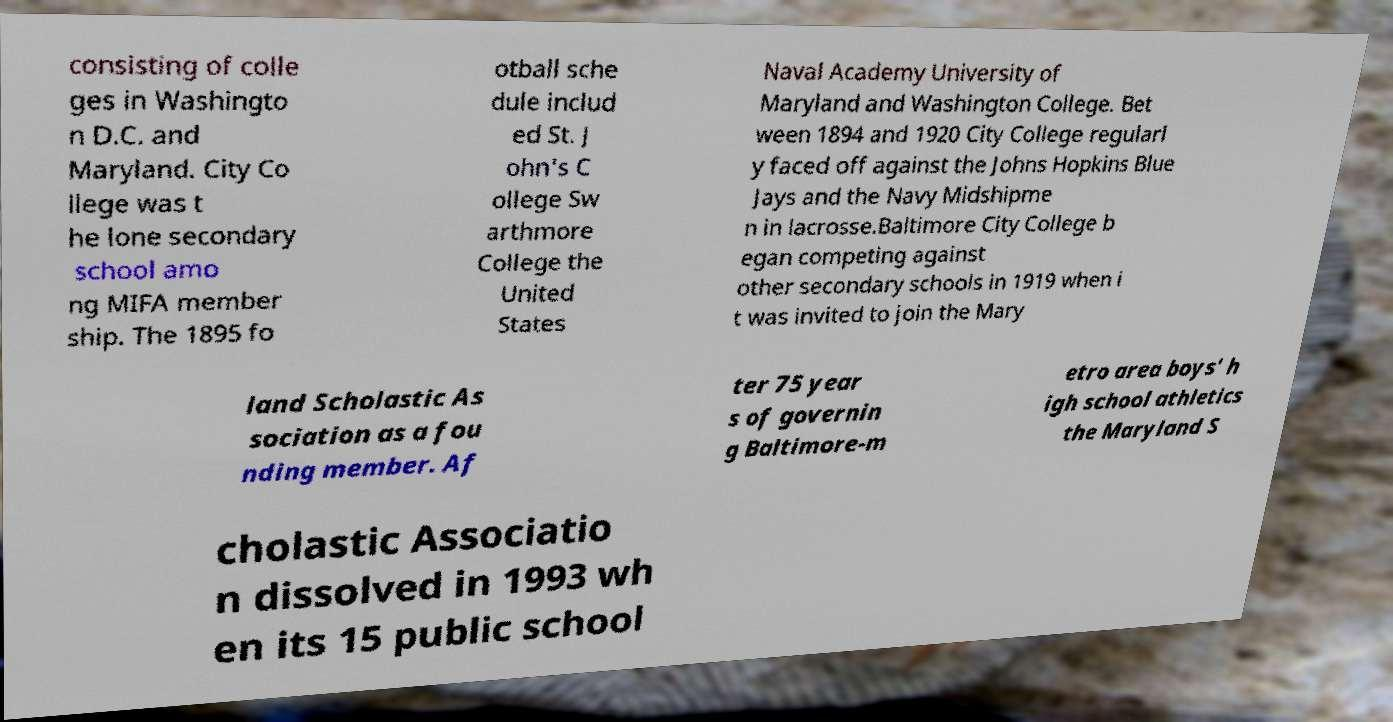Please identify and transcribe the text found in this image. consisting of colle ges in Washingto n D.C. and Maryland. City Co llege was t he lone secondary school amo ng MIFA member ship. The 1895 fo otball sche dule includ ed St. J ohn's C ollege Sw arthmore College the United States Naval Academy University of Maryland and Washington College. Bet ween 1894 and 1920 City College regularl y faced off against the Johns Hopkins Blue Jays and the Navy Midshipme n in lacrosse.Baltimore City College b egan competing against other secondary schools in 1919 when i t was invited to join the Mary land Scholastic As sociation as a fou nding member. Af ter 75 year s of governin g Baltimore-m etro area boys' h igh school athletics the Maryland S cholastic Associatio n dissolved in 1993 wh en its 15 public school 